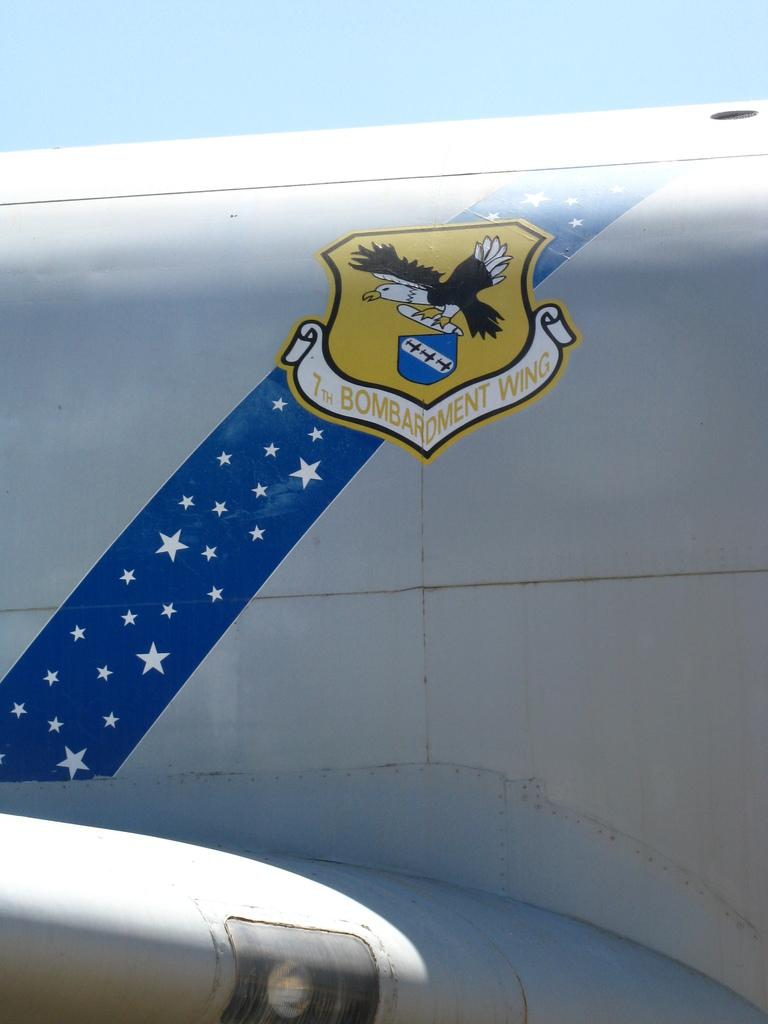<image>
Render a clear and concise summary of the photo. The side of an old plain has the emblem for the 7th bombardment wing. 